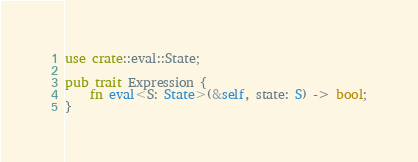<code> <loc_0><loc_0><loc_500><loc_500><_Rust_>use crate::eval::State;

pub trait Expression {
    fn eval<S: State>(&self, state: S) -> bool;
}
</code> 